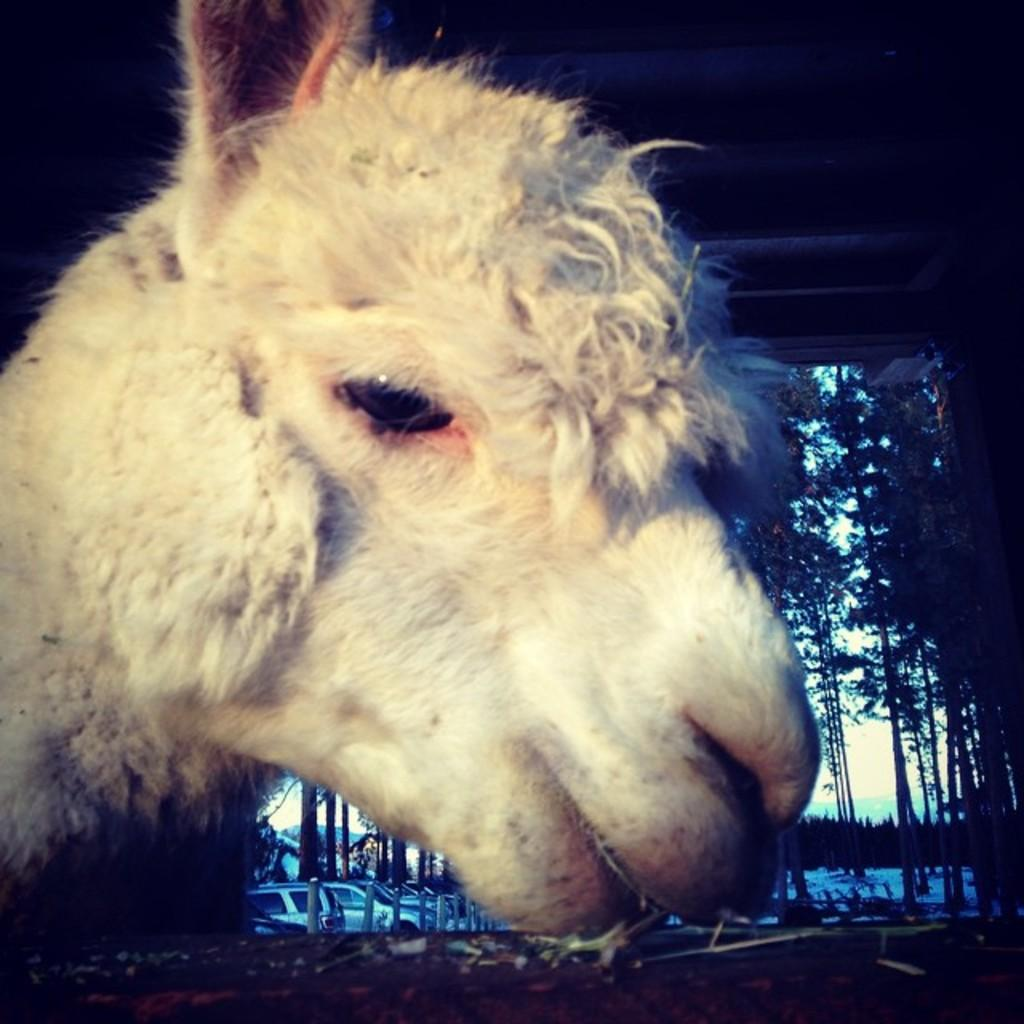What type of animal face can be seen in the image? There is a face of an animal in the image, but the specific type of animal cannot be determined from the facts provided. What else can be seen in the image besides the animal face? There are cars visible in the image. What type of vegetation is present on the ground in the image? There are trees on the ground in the image. What is visible in the background of the image? The sky is visible in the image. What type of fruit can be seen growing near the stream in the image? There is no fruit or stream present in the image; it only contains the face of an animal, cars, trees, and the sky. 